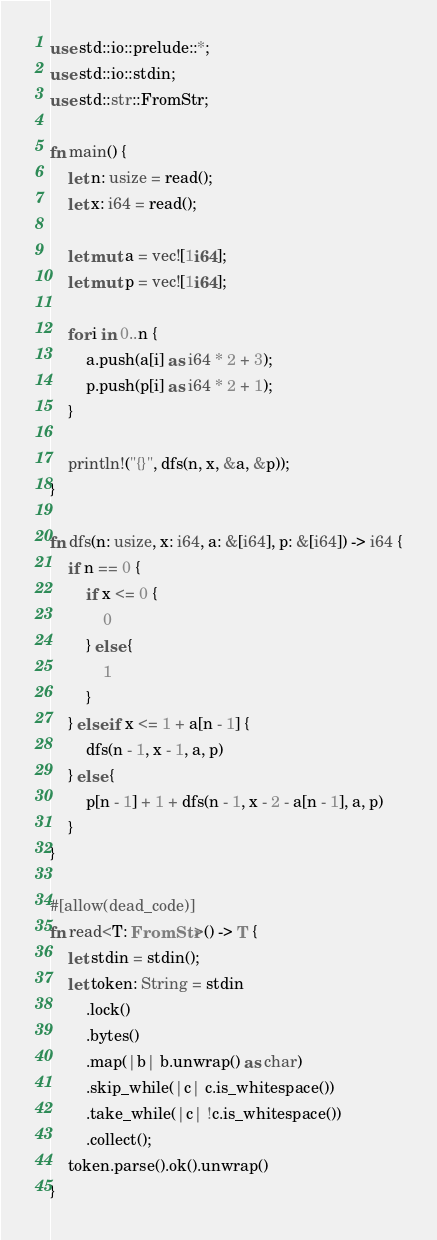Convert code to text. <code><loc_0><loc_0><loc_500><loc_500><_Rust_>use std::io::prelude::*;
use std::io::stdin;
use std::str::FromStr;

fn main() {
    let n: usize = read();
    let x: i64 = read();

    let mut a = vec![1i64];
    let mut p = vec![1i64];

    for i in 0..n {
        a.push(a[i] as i64 * 2 + 3);
        p.push(p[i] as i64 * 2 + 1);
    }

    println!("{}", dfs(n, x, &a, &p));
}

fn dfs(n: usize, x: i64, a: &[i64], p: &[i64]) -> i64 {
    if n == 0 {
        if x <= 0 {
            0
        } else {
            1
        }
    } else if x <= 1 + a[n - 1] {
        dfs(n - 1, x - 1, a, p)
    } else {
        p[n - 1] + 1 + dfs(n - 1, x - 2 - a[n - 1], a, p)
    }
}

#[allow(dead_code)]
fn read<T: FromStr>() -> T {
    let stdin = stdin();
    let token: String = stdin
        .lock()
        .bytes()
        .map(|b| b.unwrap() as char)
        .skip_while(|c| c.is_whitespace())
        .take_while(|c| !c.is_whitespace())
        .collect();
    token.parse().ok().unwrap()
}
</code> 